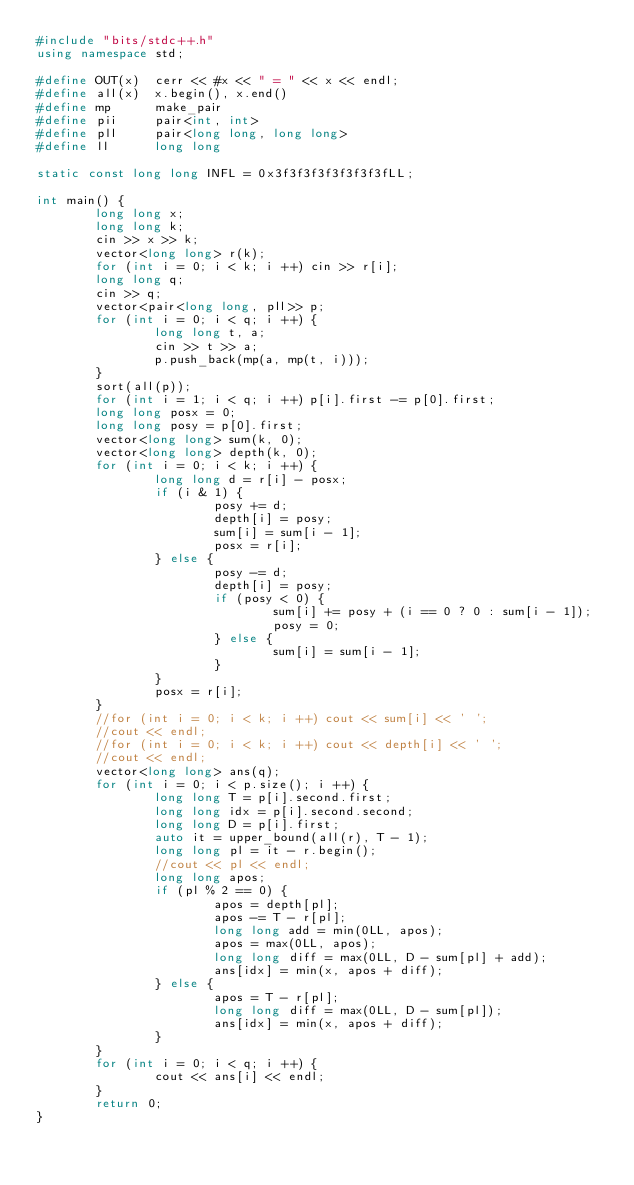<code> <loc_0><loc_0><loc_500><loc_500><_C++_>#include "bits/stdc++.h"
using namespace std;

#define OUT(x)  cerr << #x << " = " << x << endl;
#define all(x)  x.begin(), x.end()
#define mp      make_pair
#define pii     pair<int, int>
#define pll     pair<long long, long long>
#define ll      long long

static const long long INFL = 0x3f3f3f3f3f3f3f3fLL;

int main() {
        long long x;
        long long k;
        cin >> x >> k;
        vector<long long> r(k);
        for (int i = 0; i < k; i ++) cin >> r[i];
        long long q;
        cin >> q;
        vector<pair<long long, pll>> p;
        for (int i = 0; i < q; i ++) {
                long long t, a;
                cin >> t >> a;
                p.push_back(mp(a, mp(t, i)));
        }
        sort(all(p));
        for (int i = 1; i < q; i ++) p[i].first -= p[0].first;
        long long posx = 0;
        long long posy = p[0].first;
        vector<long long> sum(k, 0);
        vector<long long> depth(k, 0);
        for (int i = 0; i < k; i ++) {
                long long d = r[i] - posx;
                if (i & 1) { 
                        posy += d;
                        depth[i] = posy;
                        sum[i] = sum[i - 1];
                        posx = r[i];
                } else {
                        posy -= d;
                        depth[i] = posy;
                        if (posy < 0) { 
                                sum[i] += posy + (i == 0 ? 0 : sum[i - 1]);
                                posy = 0;
                        } else {
                                sum[i] = sum[i - 1];
                        }
                }
                posx = r[i];
        }
        //for (int i = 0; i < k; i ++) cout << sum[i] << ' ';
        //cout << endl;
        //for (int i = 0; i < k; i ++) cout << depth[i] << ' ';
        //cout << endl;
        vector<long long> ans(q);
        for (int i = 0; i < p.size(); i ++) {
                long long T = p[i].second.first;
                long long idx = p[i].second.second;
                long long D = p[i].first;
                auto it = upper_bound(all(r), T - 1);
                long long pl = it - r.begin();
                //cout << pl << endl;
                long long apos;
                if (pl % 2 == 0) {
                        apos = depth[pl];
                        apos -= T - r[pl];
                        long long add = min(0LL, apos);
                        apos = max(0LL, apos);
                        long long diff = max(0LL, D - sum[pl] + add);
                        ans[idx] = min(x, apos + diff);
                } else {
                        apos = T - r[pl];
                        long long diff = max(0LL, D - sum[pl]);
                        ans[idx] = min(x, apos + diff);
                }
        }
        for (int i = 0; i < q; i ++) {
                cout << ans[i] << endl;
        }
        return 0;
}
</code> 